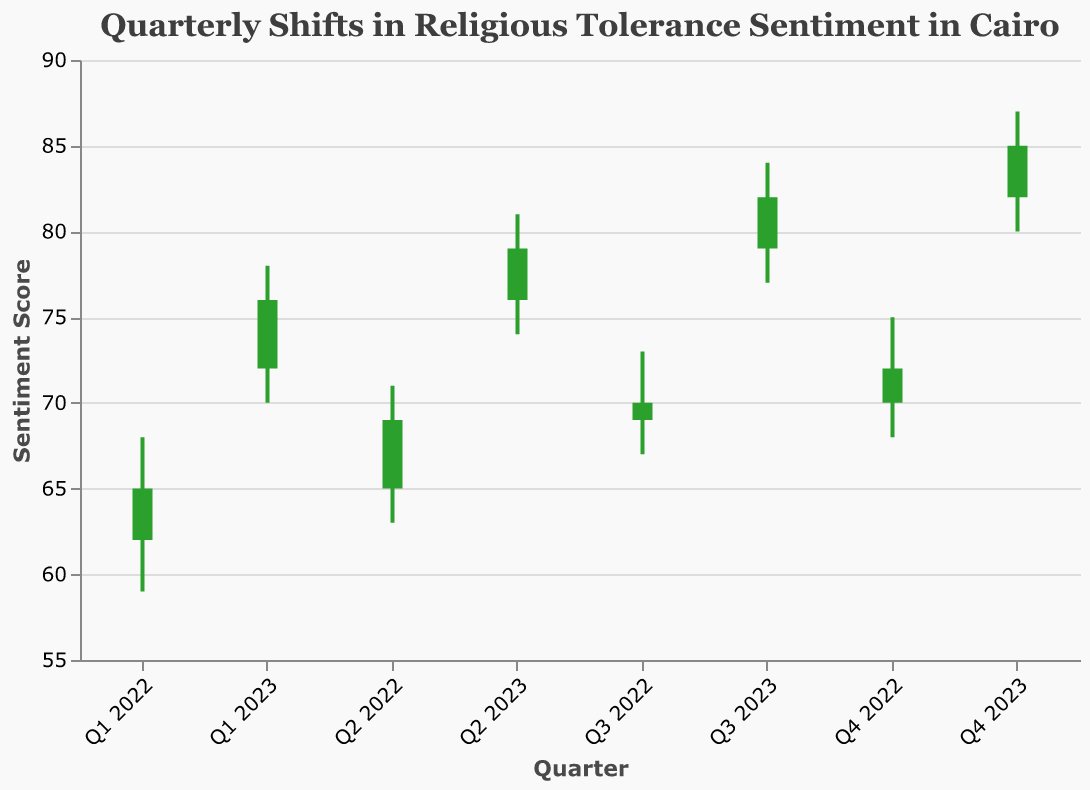What's the overall trend in public sentiment towards religious tolerance from Q1 2022 to Q4 2023? The sentiment starts at 65 in Q1 2022 and increases to 85 by Q4 2023, indicating a rising trend.
Answer: Rising Which quarter has the highest sentiment score close? Q4 2023 has the highest closing sentiment score of 85.
Answer: Q4 2023 Was there any quarter where the sentiment score decreased from the opening to the closing? No, in all listed quarters, the closing sentiment score is higher than the opening score.
Answer: No What is the range of sentiment scores for Q3 2023? The range can be calculated by subtracting the low (77) from the high (84) score: 84 - 77 = 7.
Answer: 7 How does the lowest sentiment score in Q4 2022 compare to the highest sentiment score in Q3 2022? Q4 2022's low is 68, and Q3 2022's high is 73. So, 68 is 5 points lower than 73.
Answer: 5 points lower What is the average opening sentiment score for the year 2022? The opening scores for 2022 are 62, 65, 69, and 70. The average is calculated as (62 + 65 + 69 + 70) / 4 = 66.5.
Answer: 66.5 Which quarter shows the greatest increase in closing sentiment score compared to its previous quarter? The greatest increase happens between Q1 2023 and Q2 2023, where the closing score increases from 76 to 79, a difference of 3 points.
Answer: Q2 2023 What was the sentiment score's highest fluctuation within a single quarter? The highest fluctuation is observed in Q2 2023, with a low of 74 and a high of 81. The fluctuation is 81 - 74 = 7 points.
Answer: 7 points 